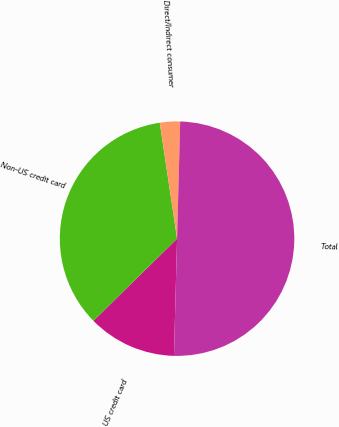Convert chart. <chart><loc_0><loc_0><loc_500><loc_500><pie_chart><fcel>US credit card<fcel>Non-US credit card<fcel>Direct/Indirect consumer<fcel>Total<nl><fcel>12.22%<fcel>35.0%<fcel>2.78%<fcel>50.0%<nl></chart> 